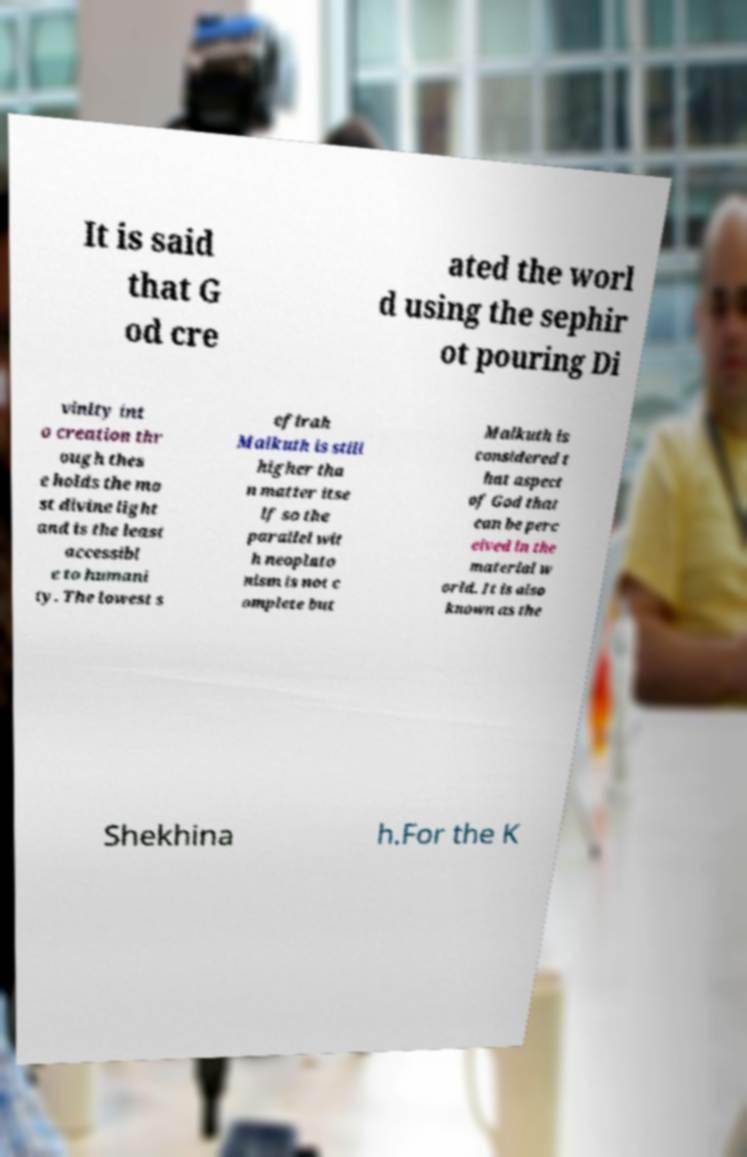Please read and relay the text visible in this image. What does it say? It is said that G od cre ated the worl d using the sephir ot pouring Di vinity int o creation thr ough thes e holds the mo st divine light and is the least accessibl e to humani ty. The lowest s efirah Malkuth is still higher tha n matter itse lf so the parallel wit h neoplato nism is not c omplete but Malkuth is considered t hat aspect of God that can be perc eived in the material w orld. It is also known as the Shekhina h.For the K 